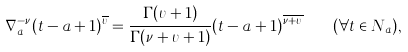<formula> <loc_0><loc_0><loc_500><loc_500>\nabla _ { a } ^ { - \nu } ( t - a + 1 ) ^ { \overline { \upsilon } } = \frac { \Gamma ( \upsilon + 1 ) } { \Gamma ( \nu + \upsilon + 1 ) } ( t - a + 1 ) ^ { \overline { \nu + \upsilon } } \quad ( \forall { t } \in N _ { a } ) ,</formula> 